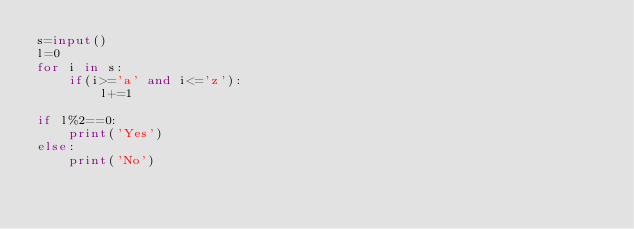Convert code to text. <code><loc_0><loc_0><loc_500><loc_500><_Python_>s=input()
l=0
for i in s:
    if(i>='a' and i<='z'):
        l+=1

if l%2==0:
    print('Yes')
else:
    print('No')
             </code> 